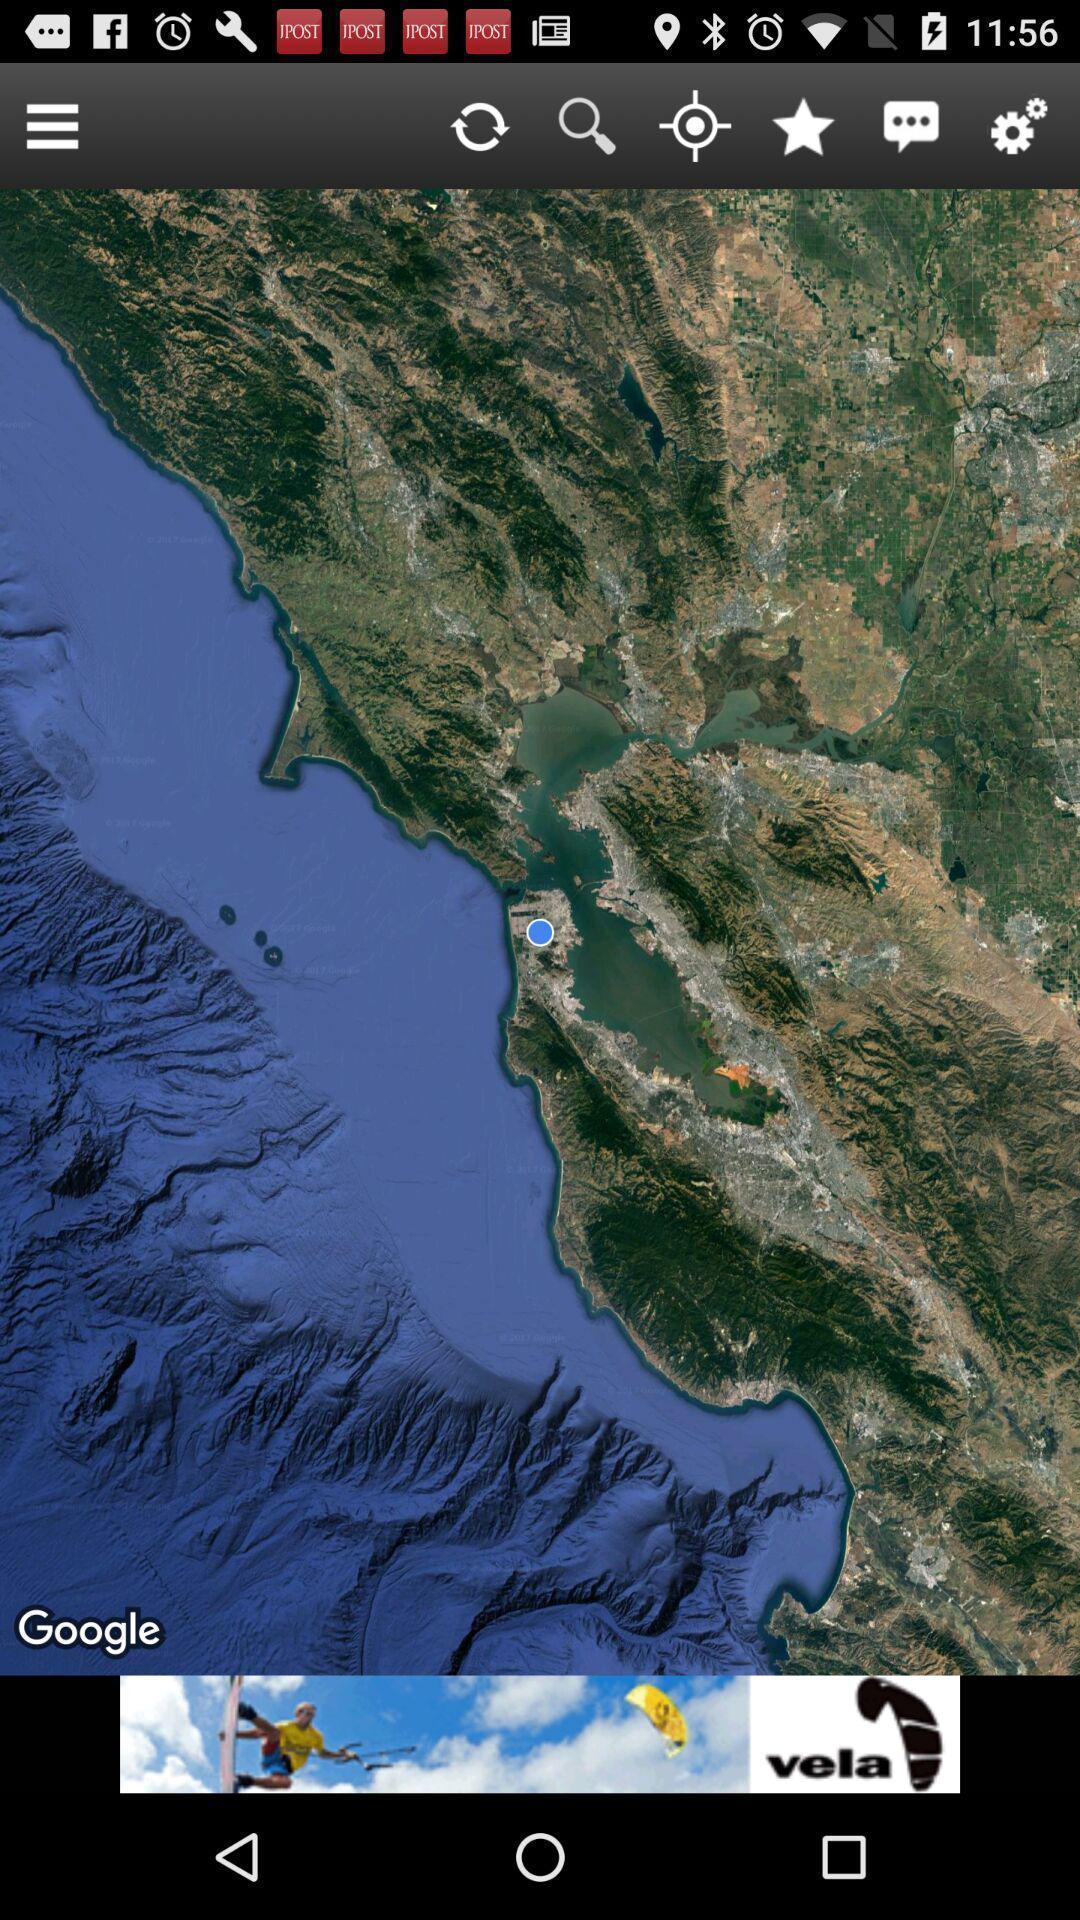What details can you identify in this image? Screen displays the image in a gaming app. 